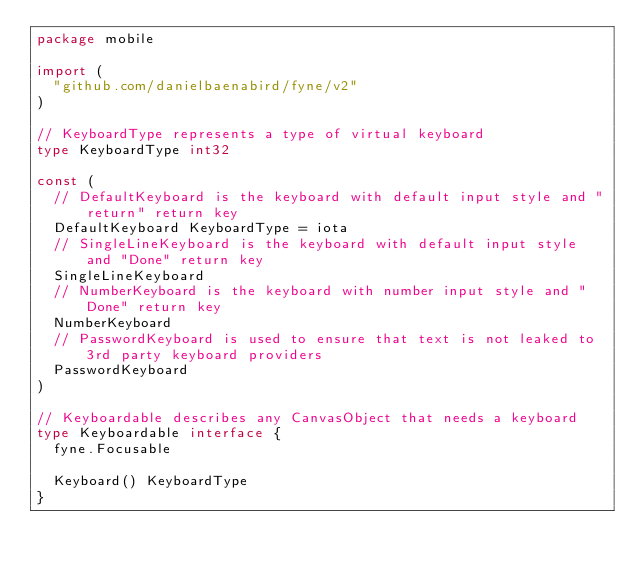Convert code to text. <code><loc_0><loc_0><loc_500><loc_500><_Go_>package mobile

import (
	"github.com/danielbaenabird/fyne/v2"
)

// KeyboardType represents a type of virtual keyboard
type KeyboardType int32

const (
	// DefaultKeyboard is the keyboard with default input style and "return" return key
	DefaultKeyboard KeyboardType = iota
	// SingleLineKeyboard is the keyboard with default input style and "Done" return key
	SingleLineKeyboard
	// NumberKeyboard is the keyboard with number input style and "Done" return key
	NumberKeyboard
	// PasswordKeyboard is used to ensure that text is not leaked to 3rd party keyboard providers
	PasswordKeyboard
)

// Keyboardable describes any CanvasObject that needs a keyboard
type Keyboardable interface {
	fyne.Focusable

	Keyboard() KeyboardType
}
</code> 